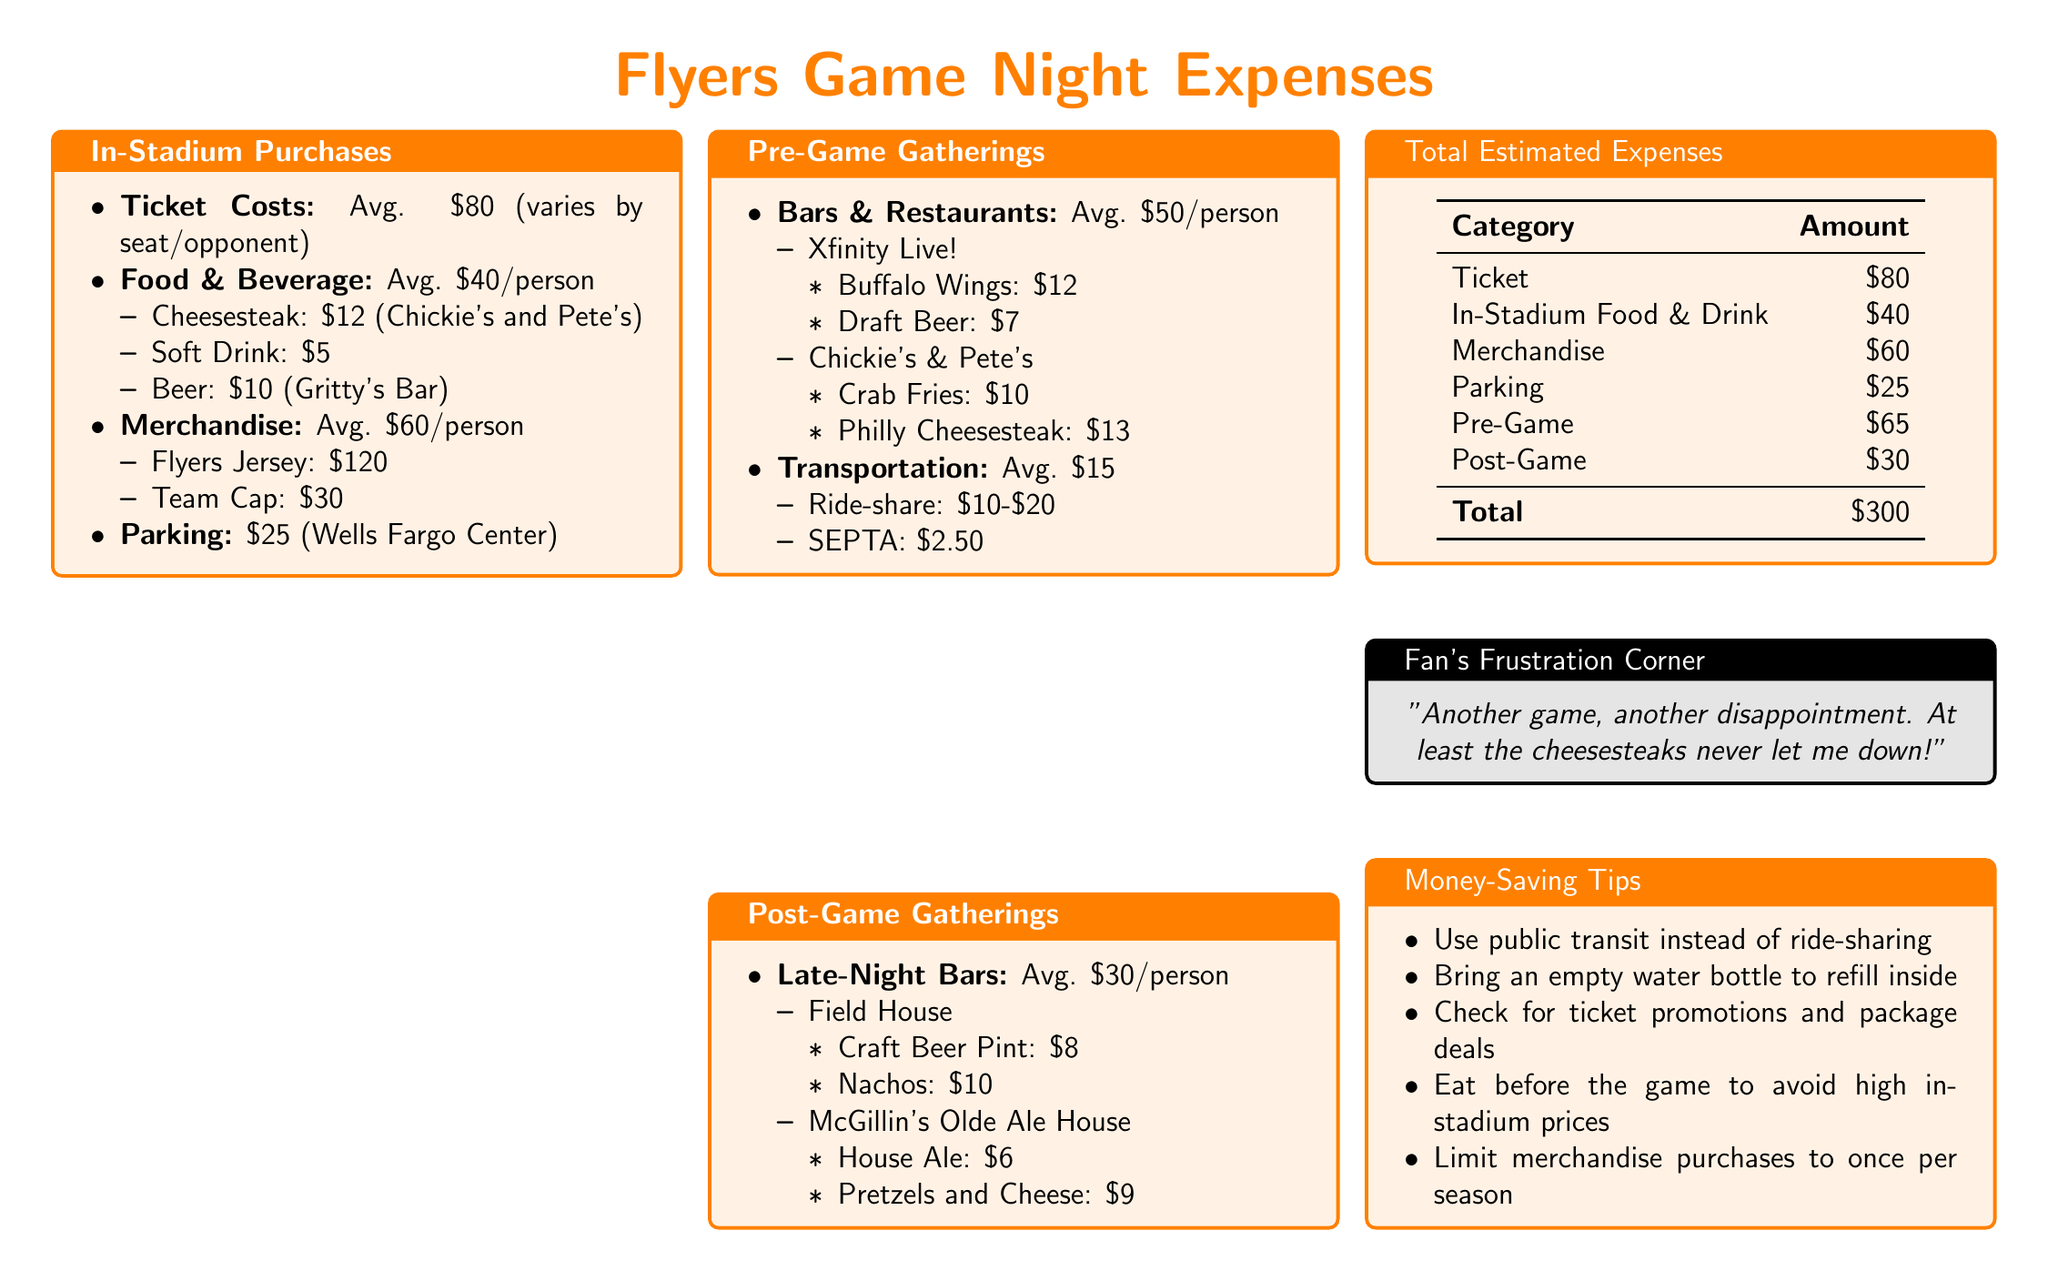What is the average cost of a ticket? The average ticket cost is stated as varying by seat/opponent but on average it is $80.
Answer: $80 How much do in-stadium food and beverage cost on average? The document states the average cost for food and beverage is $40 per person.
Answer: $40 What is the average expense for merchandise per person? The document lists the average merchandise expense as $60 per person.
Answer: $60 What is the average cost of a ride-share for transportation? The report notes that ride-share expenses can range from $10 to $20, averaging towards $15.
Answer: $15 What is the total estimated expenses for one game night? The total expenses are calculated by summing up all categories listed in the report, which is $300.
Answer: $300 What do fans tend to spend on post-game gatherings? According to the document, the average expense for post-game gatherings is $30 per person.
Answer: $30 Which food item costs $12 at Xfinity Live! The document details that Buffalo Wings are priced at $12.
Answer: Buffalo Wings What is the parking fee at the Wells Fargo Center? The parking cost listed in the report is $25.
Answer: $25 What is a key tip for saving money on game nights? The document suggests using public transit instead of ride-sharing as a money-saving tip.
Answer: Use public transit 